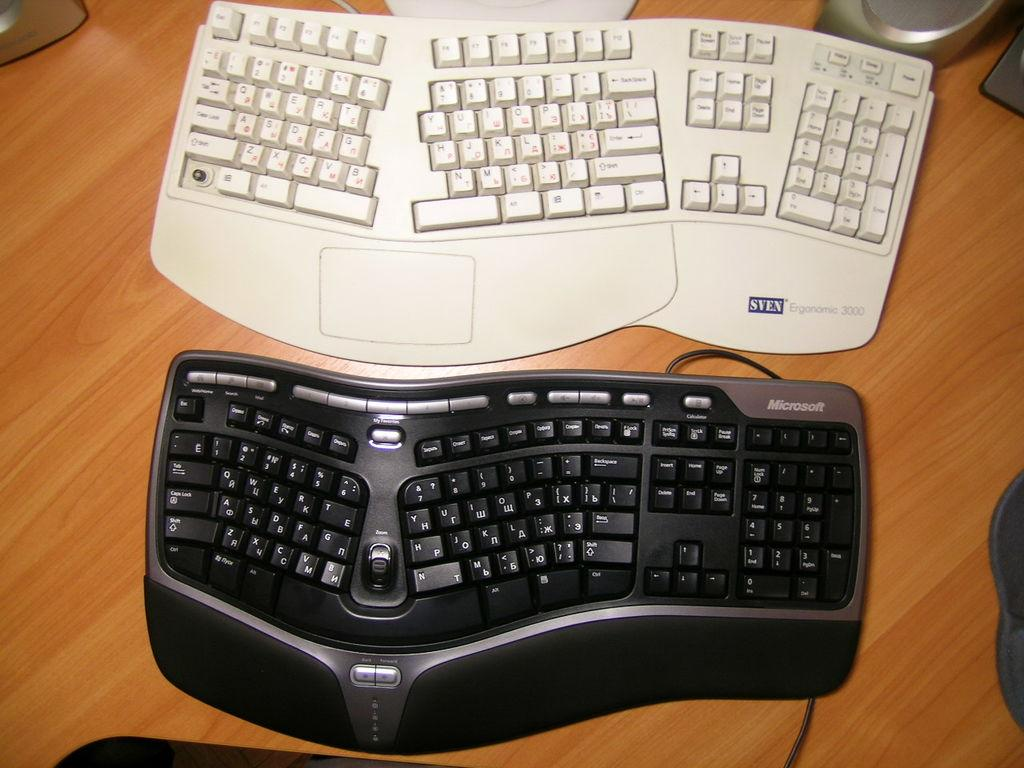<image>
Give a short and clear explanation of the subsequent image. A beige Sven keyboard is above a black Microsoft keyboard. 